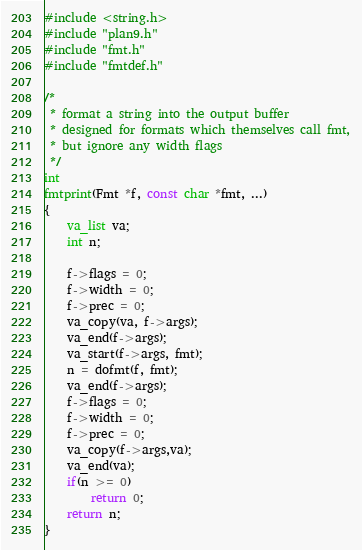Convert code to text. <code><loc_0><loc_0><loc_500><loc_500><_C_>#include <string.h>
#include "plan9.h"
#include "fmt.h"
#include "fmtdef.h"

/*
 * format a string into the output buffer
 * designed for formats which themselves call fmt,
 * but ignore any width flags
 */
int
fmtprint(Fmt *f, const char *fmt, ...)
{
	va_list va;
	int n;

	f->flags = 0;
	f->width = 0;
	f->prec = 0;
	va_copy(va, f->args);
	va_end(f->args);
	va_start(f->args, fmt);
	n = dofmt(f, fmt);
	va_end(f->args);
	f->flags = 0;
	f->width = 0;
	f->prec = 0;
	va_copy(f->args,va);
	va_end(va);
	if(n >= 0)
		return 0;
	return n;
}

</code> 